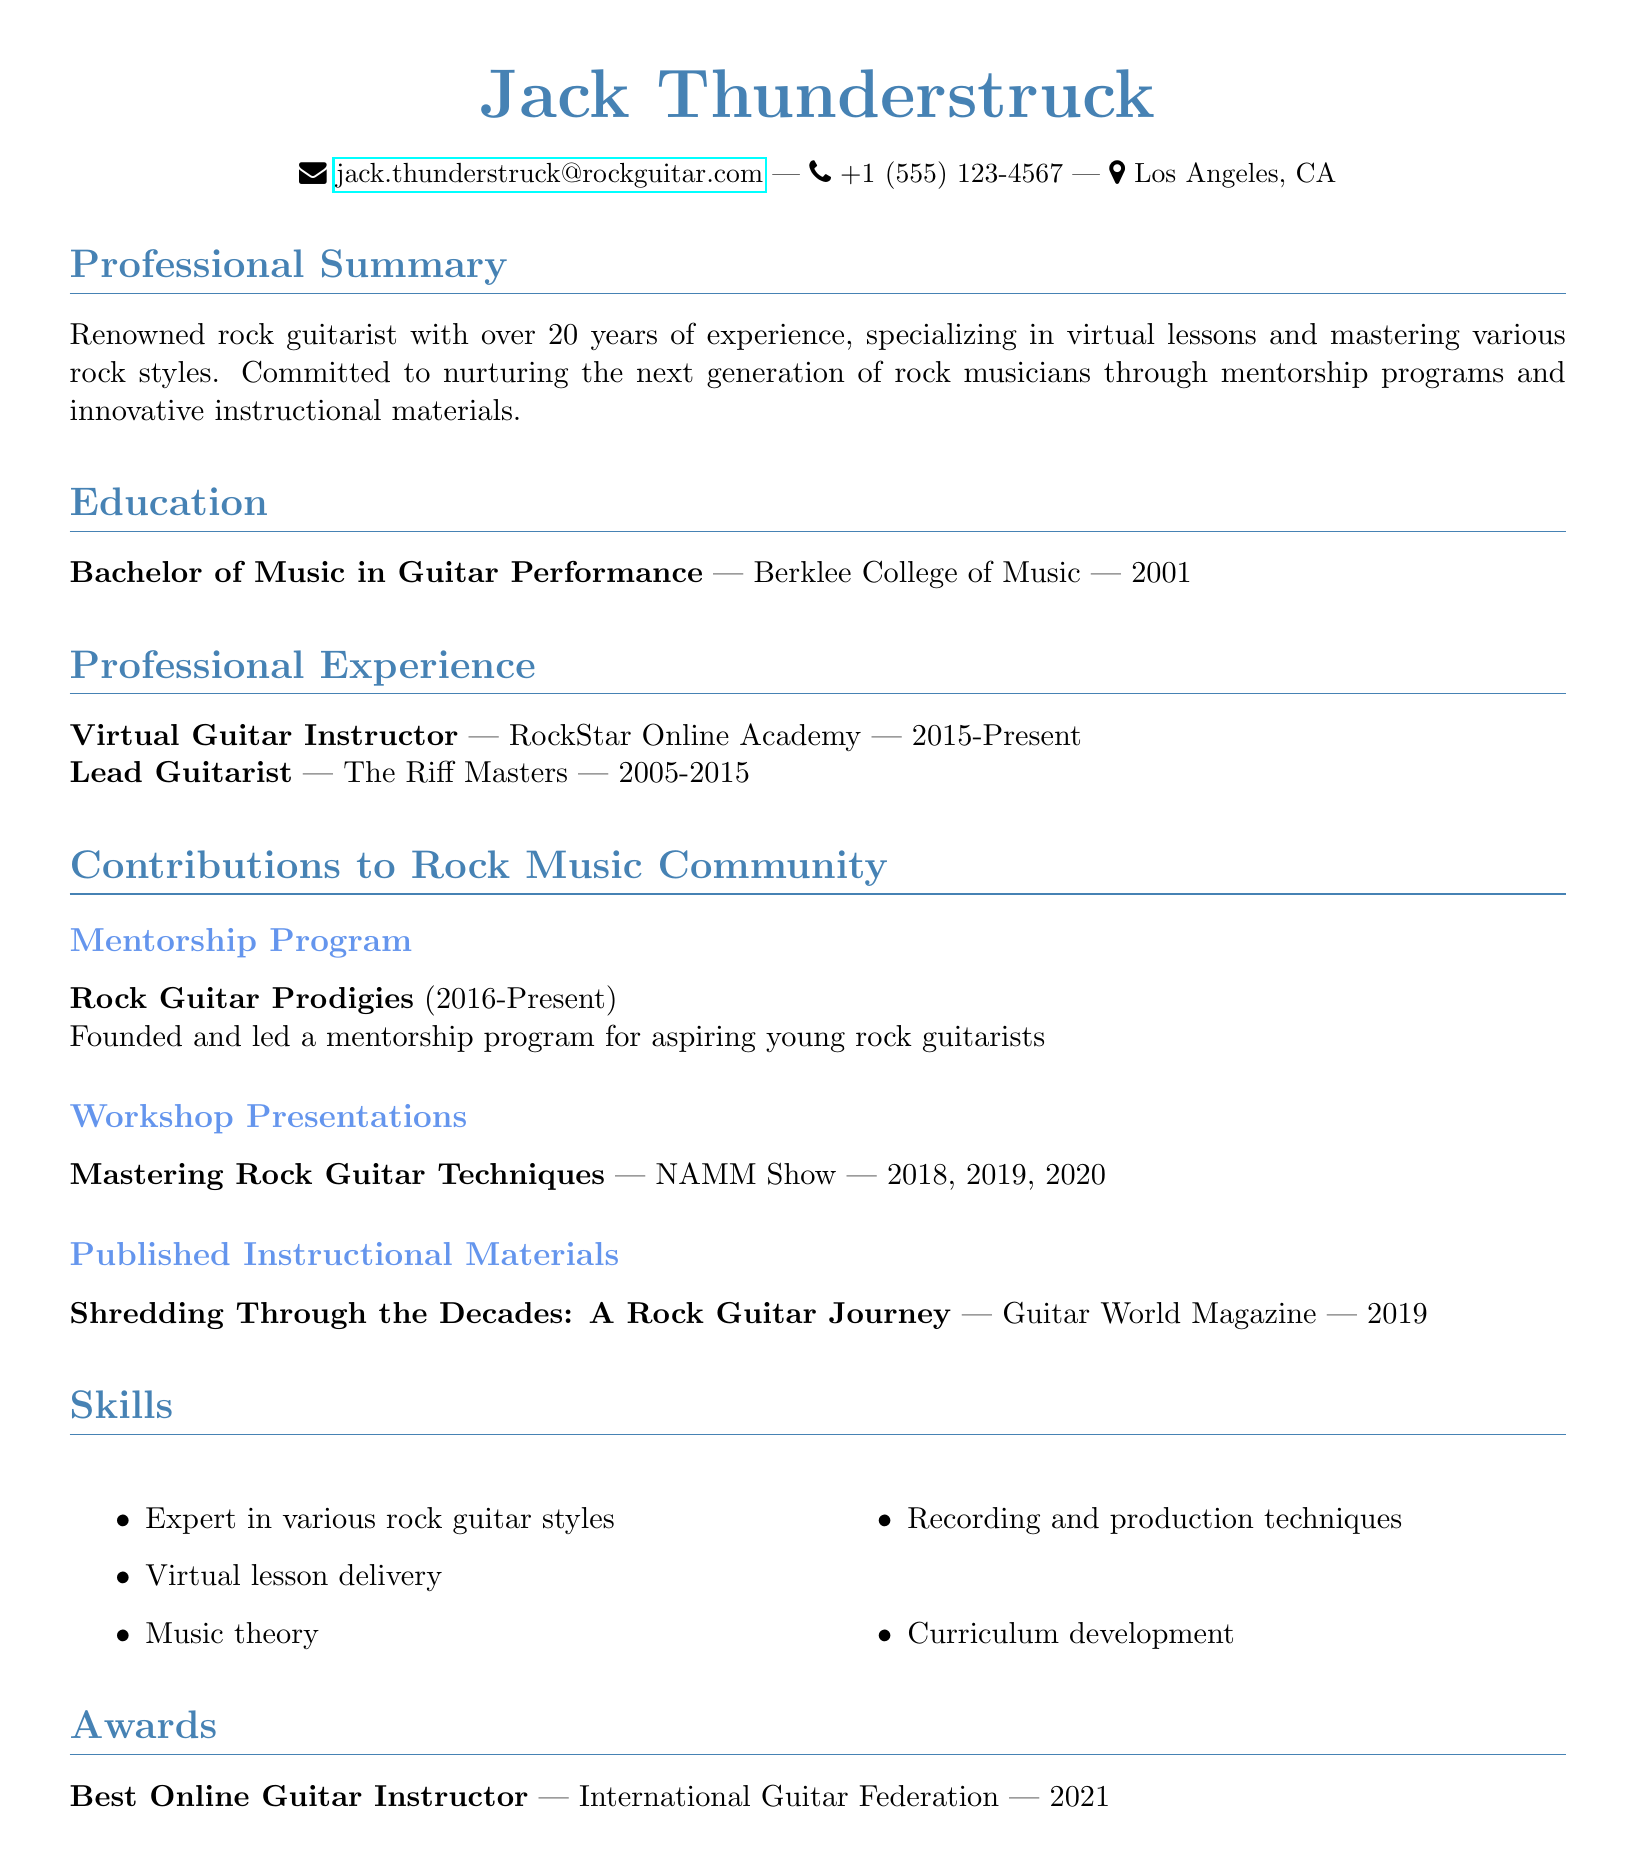What is the name of the guitarist? The document introduces the subject as Jack Thunderstruck.
Answer: Jack Thunderstruck What degree did Jack Thunderstruck earn? The educational background states he earned a Bachelor of Music in Guitar Performance.
Answer: Bachelor of Music in Guitar Performance In which year was the mentorship program founded? The mentorship program Rock Guitar Prodigies was founded in 2016.
Answer: 2016 How many years did Jack Thunderstruck play with The Riff Masters? The duration from 2005 to 2015 indicates he played for 10 years.
Answer: 10 years What is the title of the instructional material published? The document lists the publication as "Shredding Through the Decades: A Rock Guitar Journey."
Answer: Shredding Through the Decades: A Rock Guitar Journey Which organization awarded Jack the title of Best Online Guitar Instructor? The award was given by the International Guitar Federation.
Answer: International Guitar Federation How many times did Jack present at the NAMM Show? The document notes he presented three times, in 2018, 2019, and 2020.
Answer: Three times What type of positions has Jack Thunderstruck held? His positions include Lead Guitarist and Virtual Guitar Instructor.
Answer: Lead Guitarist and Virtual Guitar Instructor What is the main focus of Jack's professional summary? His professional summary emphasizes his commitment to nurturing the next generation of rock musicians.
Answer: Nurturing the next generation of rock musicians 